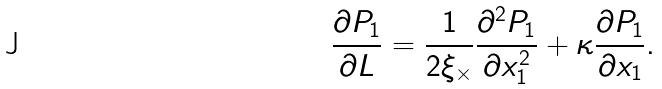<formula> <loc_0><loc_0><loc_500><loc_500>\frac { \partial P _ { 1 } } { \partial L } & = \frac { 1 } { 2 \xi _ { \times } } \frac { \partial ^ { 2 } P _ { 1 } } { \partial x _ { 1 } ^ { 2 } } + \kappa \frac { \partial P _ { 1 } } { \partial x _ { 1 } } .</formula> 